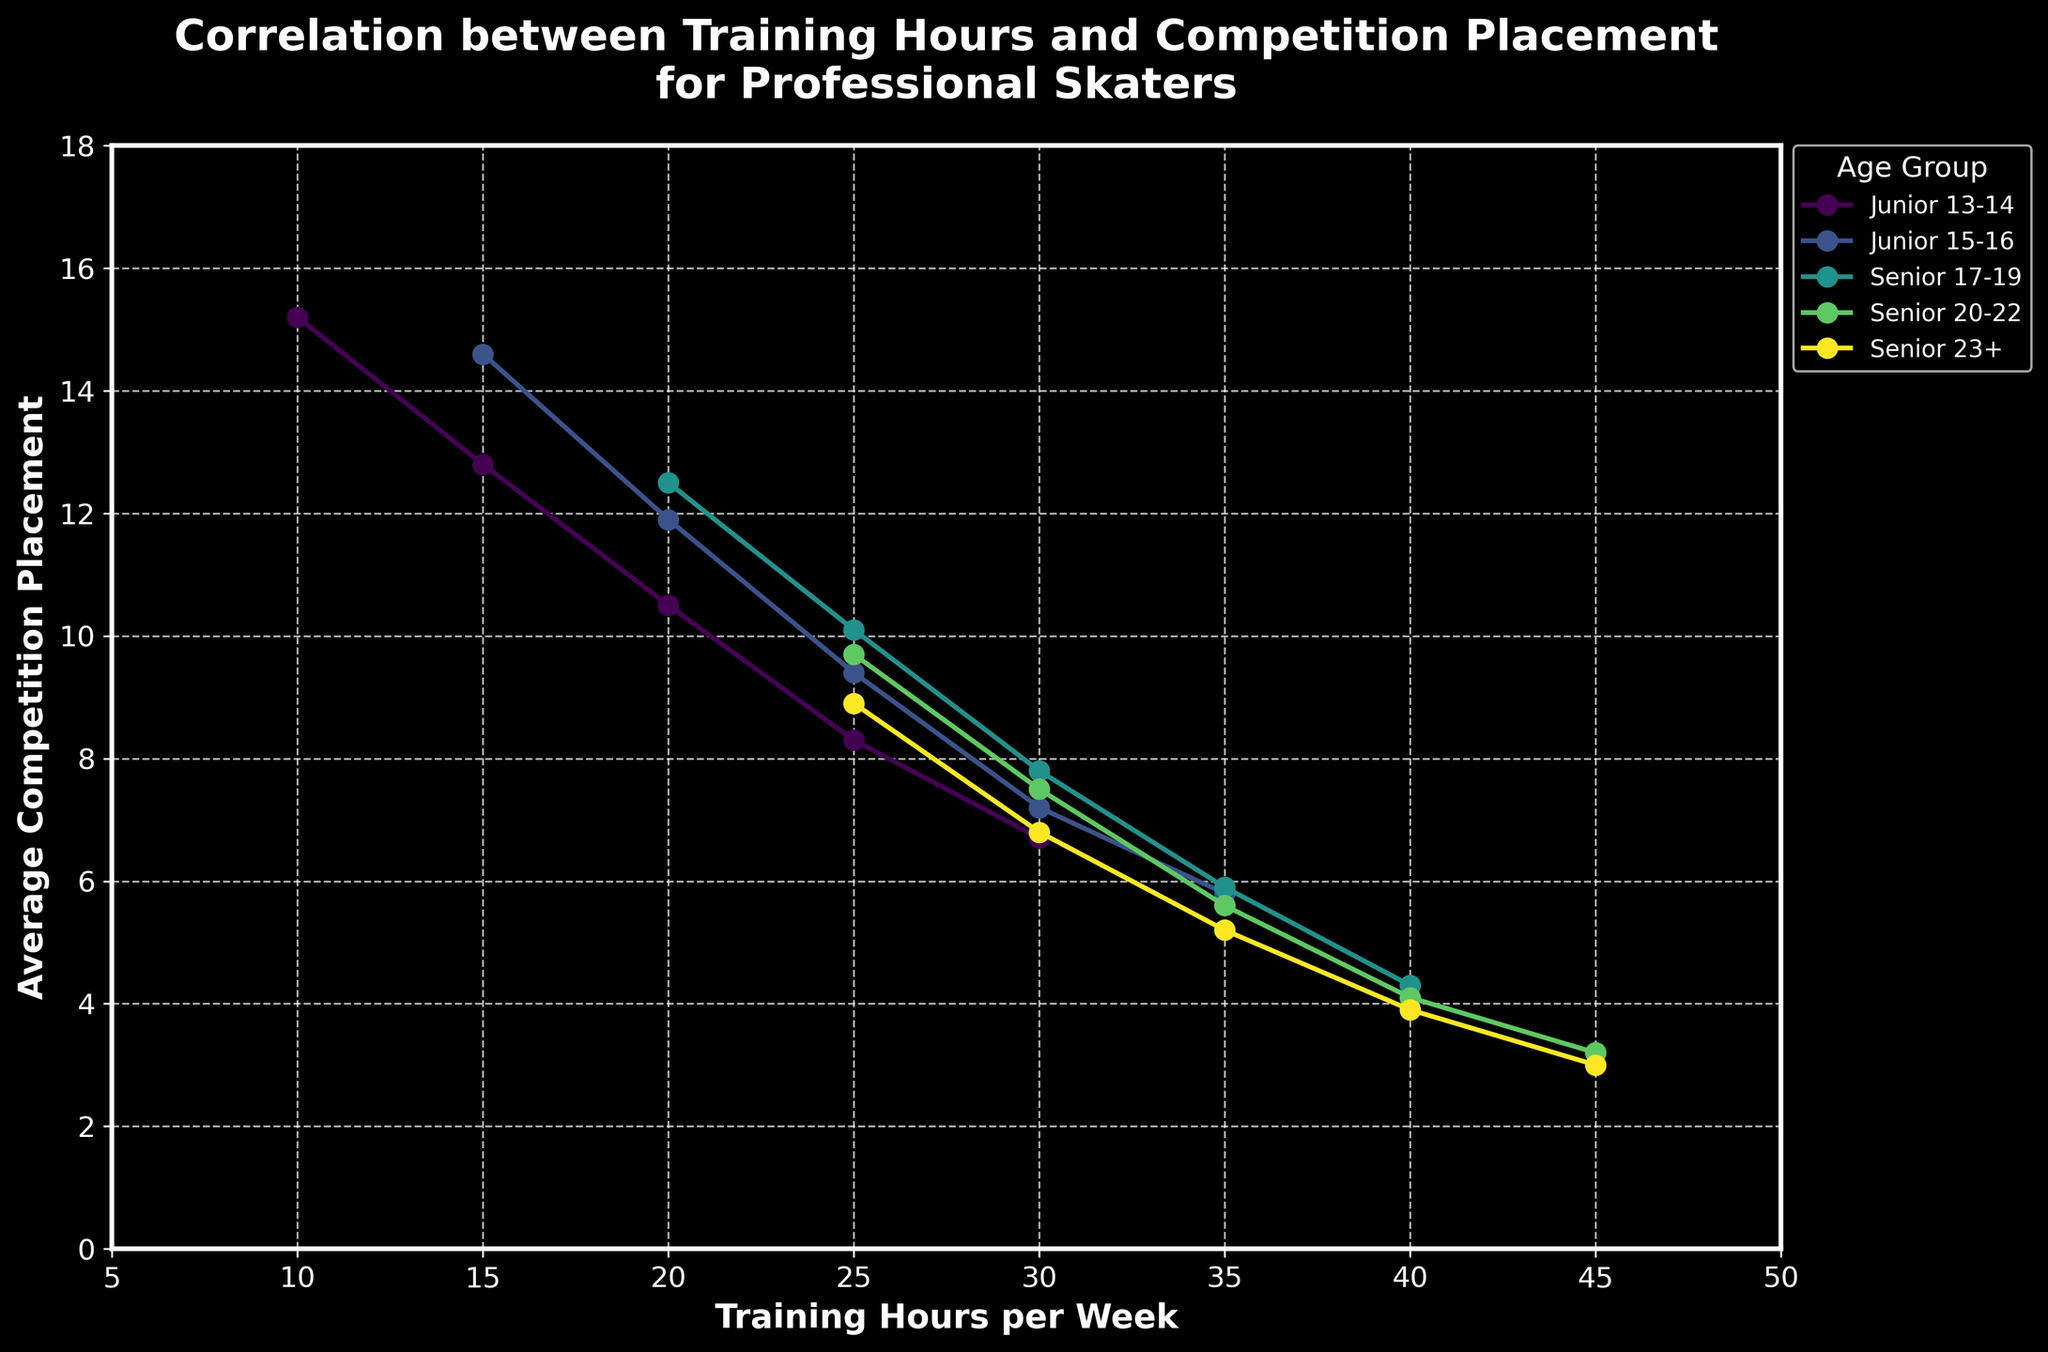What's the minimum average competition placement achieved by the Senior 23+ age group? Identify the line corresponding to the Senior 23+ age group, then find the lowest point on that line representing the minimum average competition placement.
Answer: 3.0 For the Junior 15-16 age group, what is the difference in average competition placement between 15 training hours and 35 training hours per week? Find the line representing the Junior 15-16 age group and locate the points for 15 and 35 training hours. Subtract the average placements: 14.6 (for 15 hours) - 5.8 (for 35 hours) = 8.8.
Answer: 8.8 Which age group shows the steepest decline in average competition placement as training hours increase? Compare the slopes of the lines for each age group. A steeper slope indicates a rapid decline. The trend lines can be visually observed to determine this.
Answer: Senior 23+ At what training hours per week do Senior 20-22 skaters achieve an average competition placement below 5? Locate the point on the line for Senior 20-22 age group where the average competition placement falls below 5. This occurs when training hours are greater than 35 per week.
Answer: 40 or 45 Compare the average competition placement for Junior 15-16 skaters training 15 hours per week and Senior 23+ skaters training 25 hours per week. Which group has a better (lower) placement? Identify the points on the lines for Junior 15-16 and Senior 23+ at the specified training hours (15 and 25). Compare the values: Junior 15-16 at 15 hours is 14.6, and Senior 23+ at 25 hours is 8.9.
Answer: Senior 23+ What's the median average competition placement for the Senior 17-19 age group based on the plotted points? Identify the points on the line for Senior 17-19: 12.5, 10.1, 7.8, 5.9, 4.3. Arrange in order and find the median, which is 7.8.
Answer: 7.8 For the same amount of training (30 hours per week), which age group achieves the best (lowest) average competition placement? Locate the points corresponding to 30 training hours on all lines and compare the average competition placements: Junior 13-14 (6.7), Junior 15-16 (7.2), Senior 17-19 (7.8), Senior 20-22 (7.5), Senior 23+ (6.8). The lowest value is 6.7 by Junior 13-14.
Answer: Junior 13-14 If a Senior 23+ skater increases their training from 30 to 45 hours per week, how much does their average competition placement improve? Locate the points for 30 and 45 training hours on the Senior 23+ line. Calculate the difference in placements: 6.8 (30 hours) - 3.0 (45 hours) = 3.8.
Answer: 3.8 For which age group does increasing training hours from 20 to 25 hours result in the smallest improvement in average competition placement? Find the change in average competition placement for each age group between 20 and 25 training hours. Compare the differences to determine the smallest improvement.
Answer: Senior 23+ Which age group achieves the best average competition placement with 35 training hours per week? Locate the points corresponding to 35 training hours on all lines and compare the average competition placements: Junior 15-16 (5.8), Senior 17-19 (5.9), Senior 20-22 (5.6), Senior 23+ (5.2). The lowest value is 5.2 by Senior 23+.
Answer: Senior 23+ 